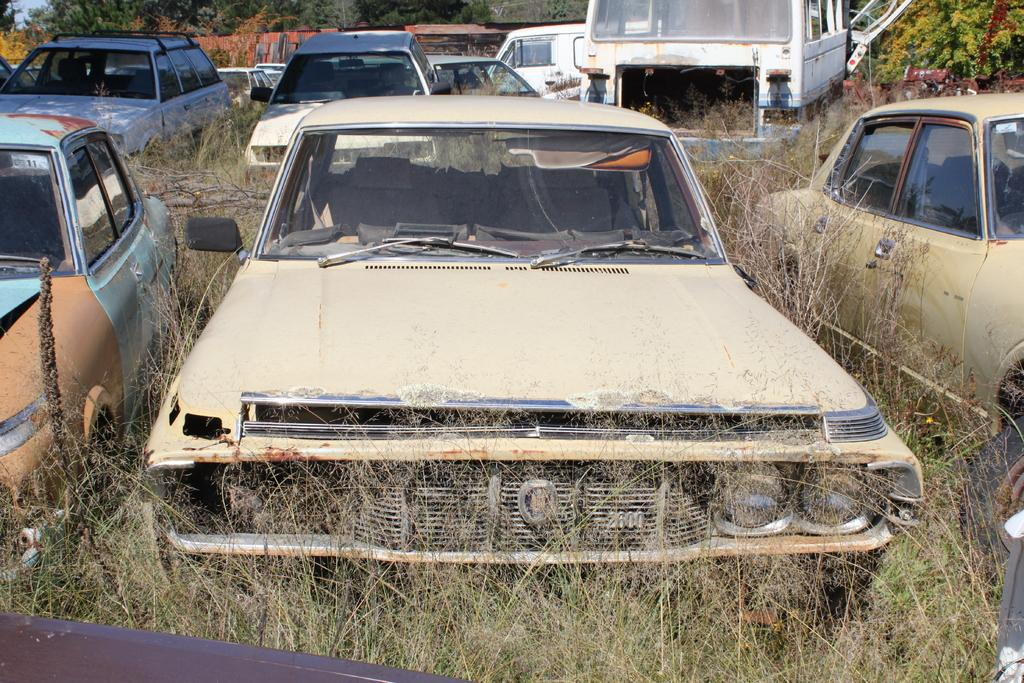What can be seen on the path in the image? There are vehicles parked on the path in the image. What is located behind the vehicles in the image? There are trees behind the vehicles in the image. What type of vegetation is visible in the image? There is grass visible in the image. What type of game is being played by the trees in the image? There is no game being played by the trees in the image; they are simply standing. Can you tell me how the guide is directing the vehicles in the image? There is no guide present in the image; it only shows vehicles parked on the path and trees behind them. 